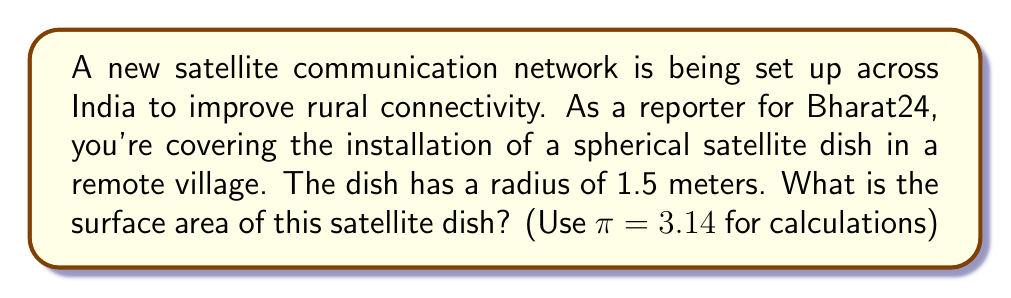Provide a solution to this math problem. To solve this problem, we need to use the formula for the surface area of a sphere. The surface area of a sphere is given by the formula:

$$A = 4\pi r^2$$

Where:
$A$ is the surface area
$r$ is the radius of the sphere

Given:
- Radius of the satellite dish, $r = 1.5$ meters
- $\pi = 3.14$

Let's substitute these values into the formula:

$$\begin{align*}
A &= 4\pi r^2 \\
&= 4 \times 3.14 \times (1.5)^2 \\
&= 4 \times 3.14 \times 2.25 \\
&= 28.26 \text{ m}^2
\end{align*}$$

[asy]
import geometry;

size(100);
draw(circle((0,0),1), blue);
draw((0,0)--(1,0), arrow=Arrow(TeXHead));
label("$r$", (0.5,0.1), N);
label("1.5 m", (0,-1.2));
[/asy]

Therefore, the surface area of the spherical satellite dish is approximately 28.26 square meters.
Answer: $28.26 \text{ m}^2$ 